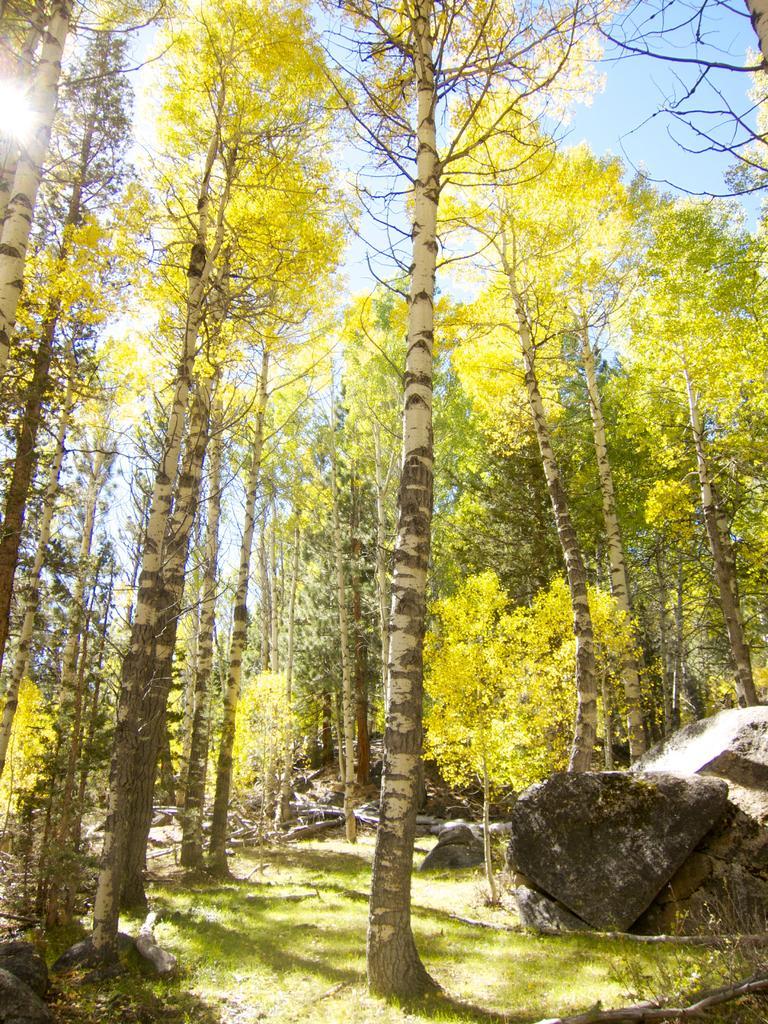In one or two sentences, can you explain what this image depicts? In this image we can see trees, rocks, grass and other objects. In the background of the image there is the sky and the sun. 